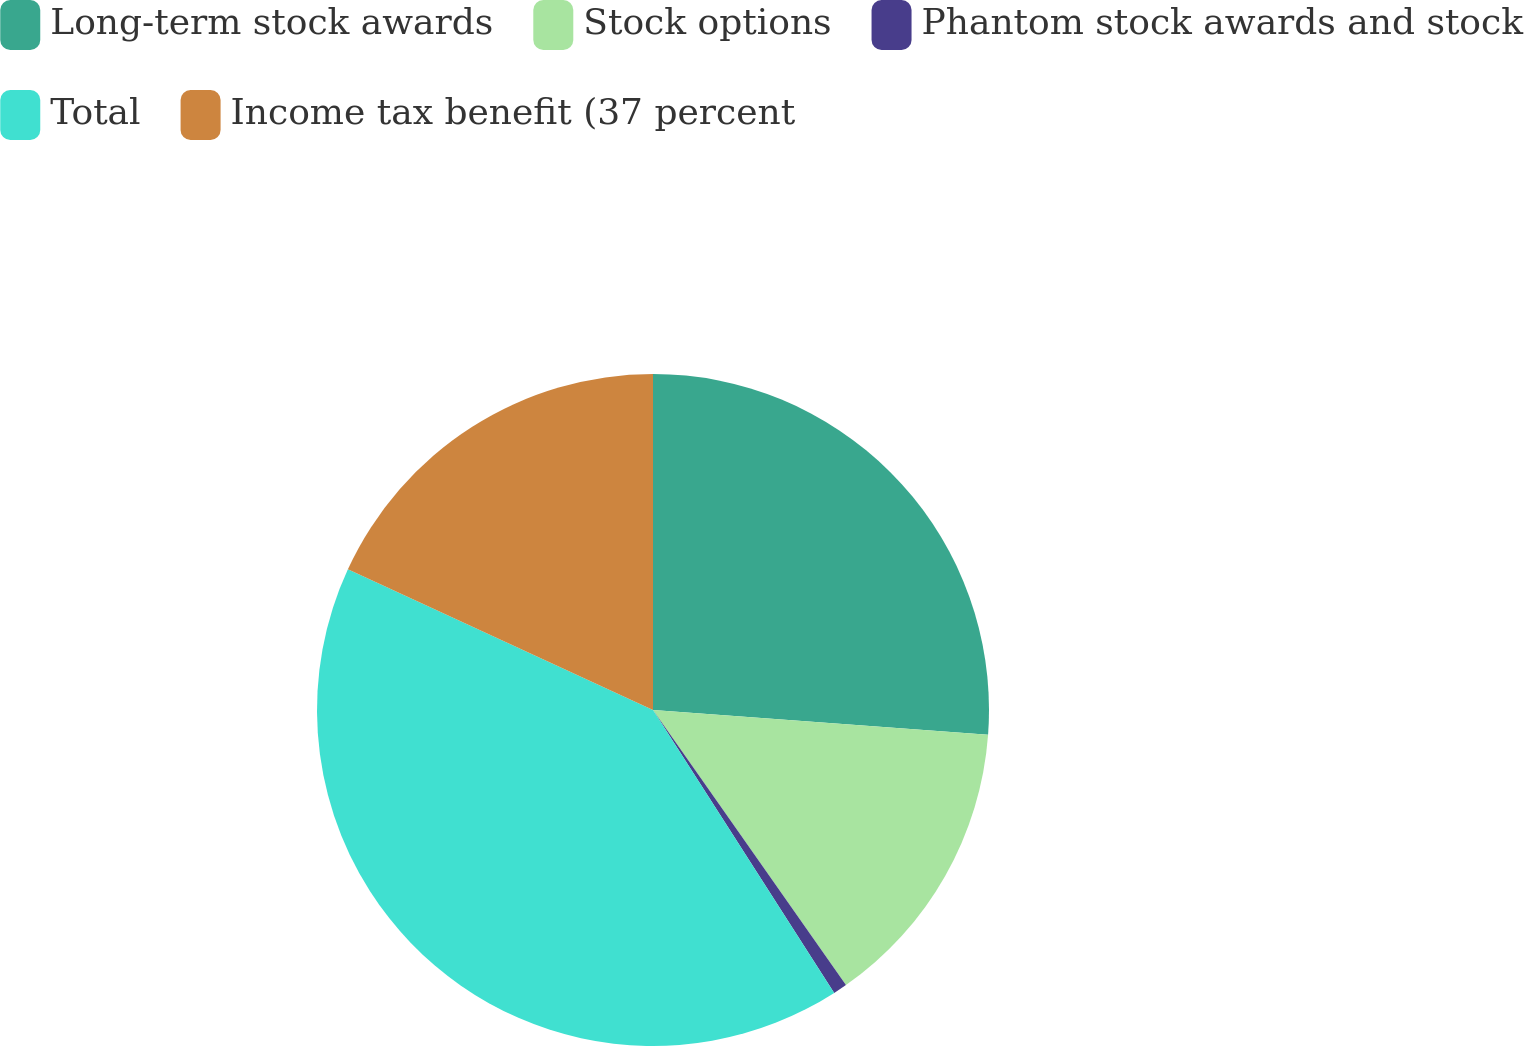<chart> <loc_0><loc_0><loc_500><loc_500><pie_chart><fcel>Long-term stock awards<fcel>Stock options<fcel>Phantom stock awards and stock<fcel>Total<fcel>Income tax benefit (37 percent<nl><fcel>26.17%<fcel>14.09%<fcel>0.67%<fcel>40.94%<fcel>18.12%<nl></chart> 